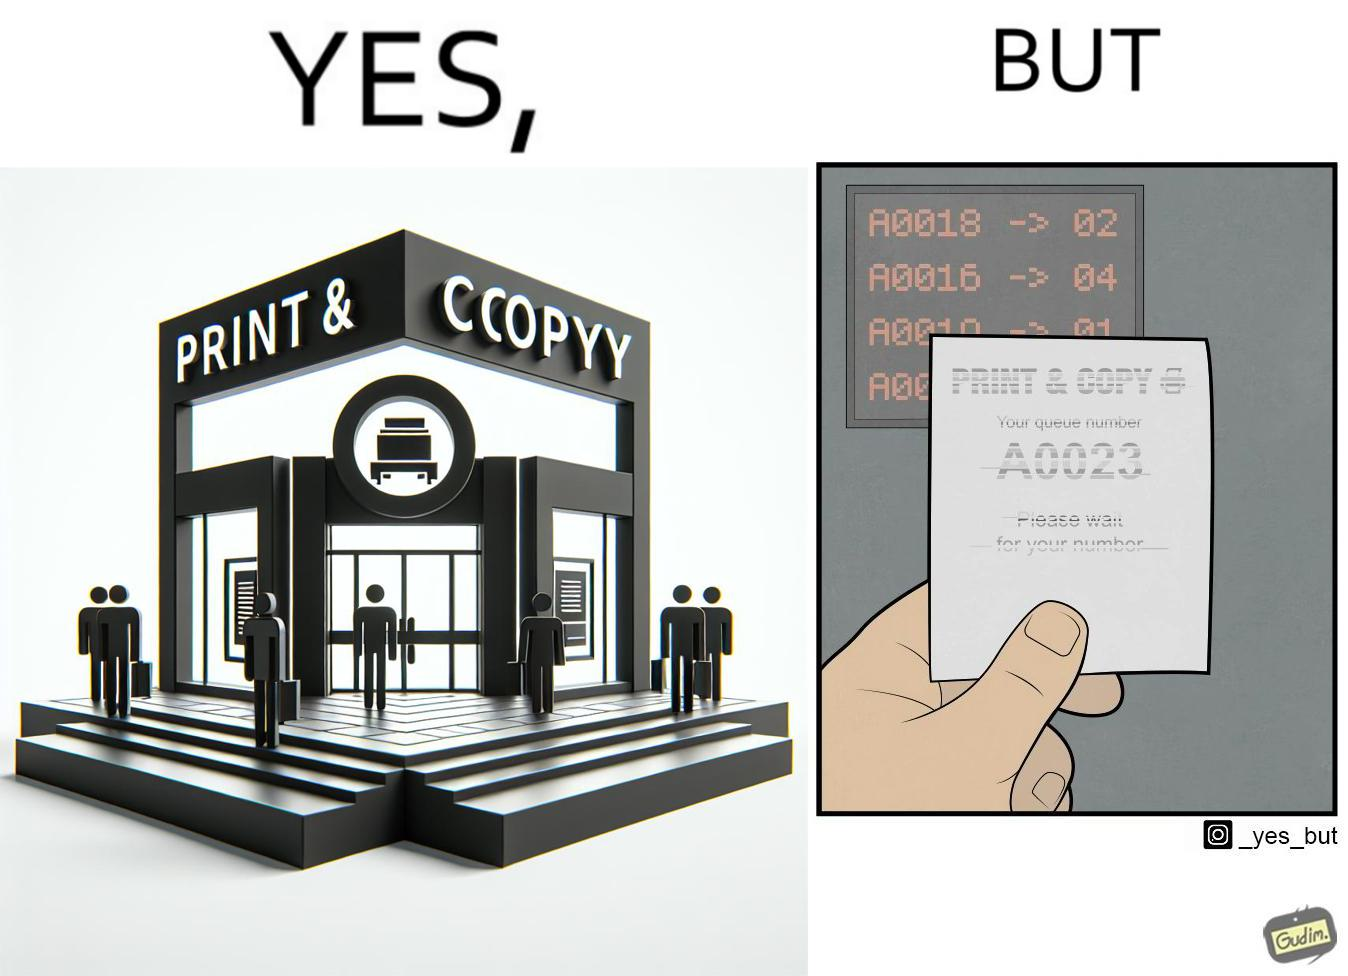What is shown in the left half versus the right half of this image? In the left part of the image: entrance to the "Print & Copy" Centre. In the right part of the image: printed waiting slip for the 'Print & Copy" Centre. 